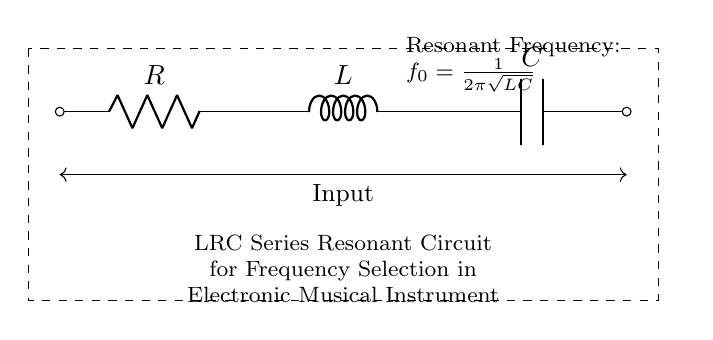What are the components in this circuit? The circuit contains a resistor, an inductor, and a capacitor. These components are represented by the labels R, L, and C respectively.
Answer: Resistor, Inductor, Capacitor What is the function of the inductor in this circuit? The inductor in this circuit is used to store energy in the form of a magnetic field and contributes to the resonant frequency of the circuit. It interacts with the capacitor to determine the resonant frequency.
Answer: Energy storage What is the resonant frequency formula shown in this circuit? The resonant frequency formula is represented as f_0 = 1 / (2π√(LC)). This relationship means the frequency is based on the values of the inductor and capacitor.
Answer: f_0 = 1 / (2π√(LC)) How does increasing the capacitance affect the resonant frequency? Increasing the capacitance will lower the resonant frequency, as the resonant frequency is inversely proportional to the square root of capacitance, according to the formula.
Answer: Lowers frequency Is this circuit for high-pass or low-pass filtering? This LRC series circuit functions primarily as a band-pass filter, allowing a specific frequency to pass while attenuating others due to its resonant nature.
Answer: Band-pass filter What is the type of connection between the resistor, inductor, and capacitor? The resistor, inductor, and capacitor are connected in series, meaning that they are connected one after the other in a single path for current flow.
Answer: Series connection How is the input to the circuit represented? The input to the circuit is depicted as arrows pointing towards the left and right ends labeled "Input", indicating where the signal enters the circuit.
Answer: Input arrows 